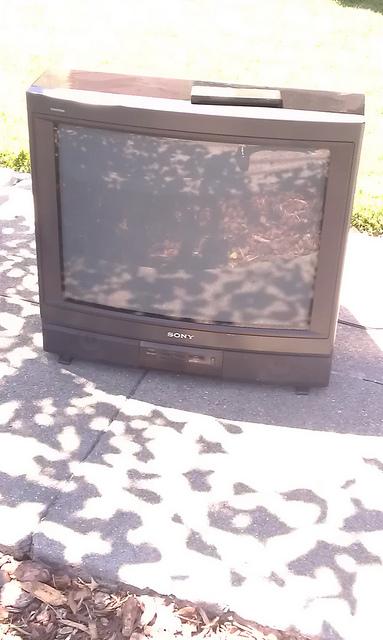Is someone throwing the TV away?
Short answer required. Yes. IS the TV outside?
Be succinct. Yes. Is the tv on?
Concise answer only. No. 